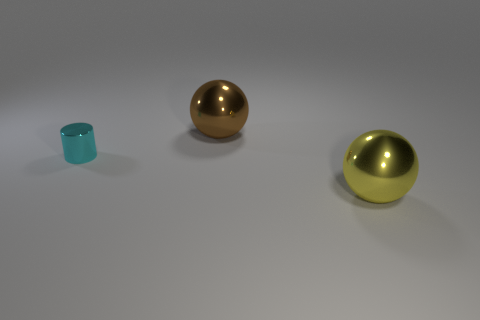Add 3 tiny yellow matte objects. How many objects exist? 6 Subtract all cylinders. How many objects are left? 2 Subtract 0 gray cylinders. How many objects are left? 3 Subtract all tiny things. Subtract all cyan things. How many objects are left? 1 Add 2 balls. How many balls are left? 4 Add 2 big things. How many big things exist? 4 